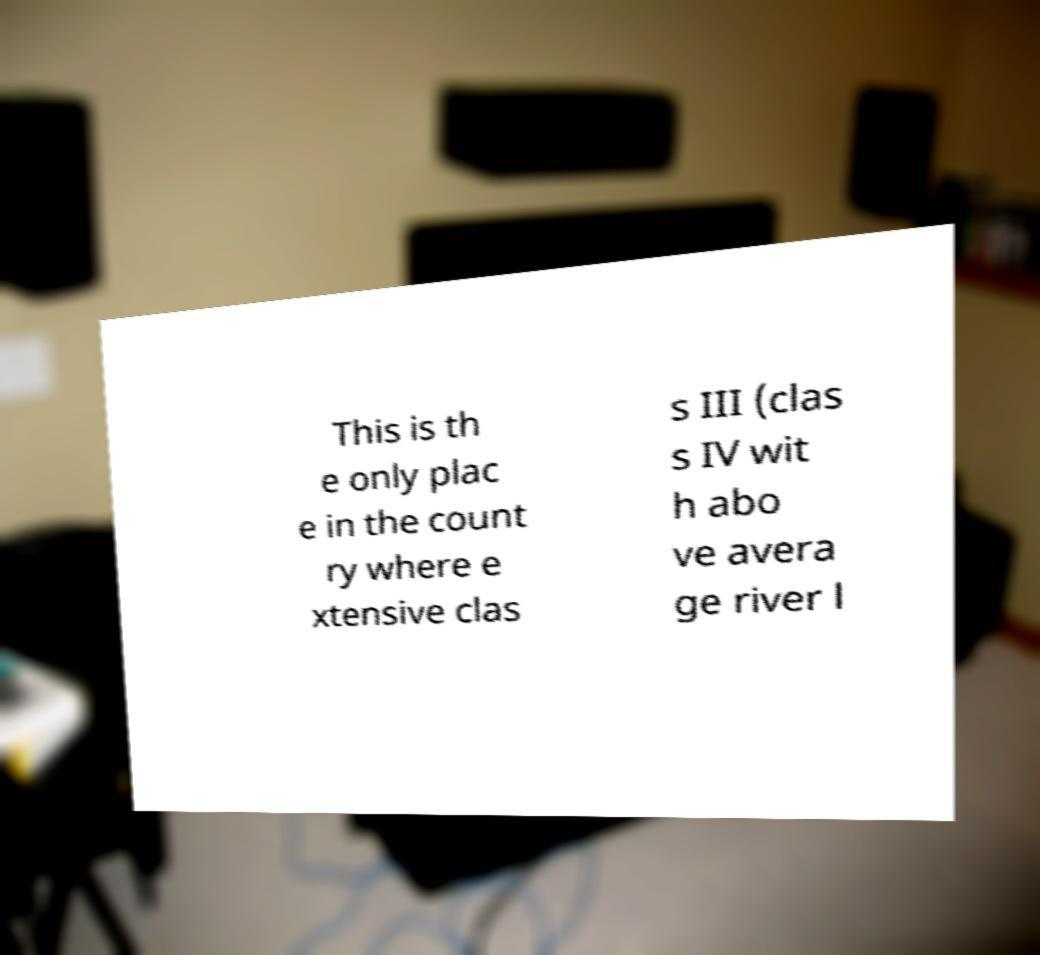For documentation purposes, I need the text within this image transcribed. Could you provide that? This is th e only plac e in the count ry where e xtensive clas s III (clas s IV wit h abo ve avera ge river l 